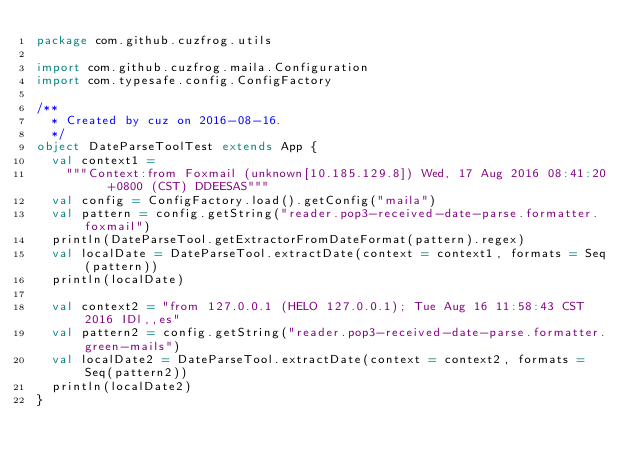Convert code to text. <code><loc_0><loc_0><loc_500><loc_500><_Scala_>package com.github.cuzfrog.utils

import com.github.cuzfrog.maila.Configuration
import com.typesafe.config.ConfigFactory

/**
  * Created by cuz on 2016-08-16.
  */
object DateParseToolTest extends App {
  val context1 =
    """Context:from Foxmail (unknown[10.185.129.8]) Wed, 17 Aug 2016 08:41:20 +0800 (CST) DDEESAS"""
  val config = ConfigFactory.load().getConfig("maila")
  val pattern = config.getString("reader.pop3-received-date-parse.formatter.foxmail")
  println(DateParseTool.getExtractorFromDateFormat(pattern).regex)
  val localDate = DateParseTool.extractDate(context = context1, formats = Seq(pattern))
  println(localDate)

  val context2 = "from 127.0.0.1 (HELO 127.0.0.1); Tue Aug 16 11:58:43 CST 2016 IDl,,es"
  val pattern2 = config.getString("reader.pop3-received-date-parse.formatter.green-mails")
  val localDate2 = DateParseTool.extractDate(context = context2, formats = Seq(pattern2))
  println(localDate2)
}
</code> 